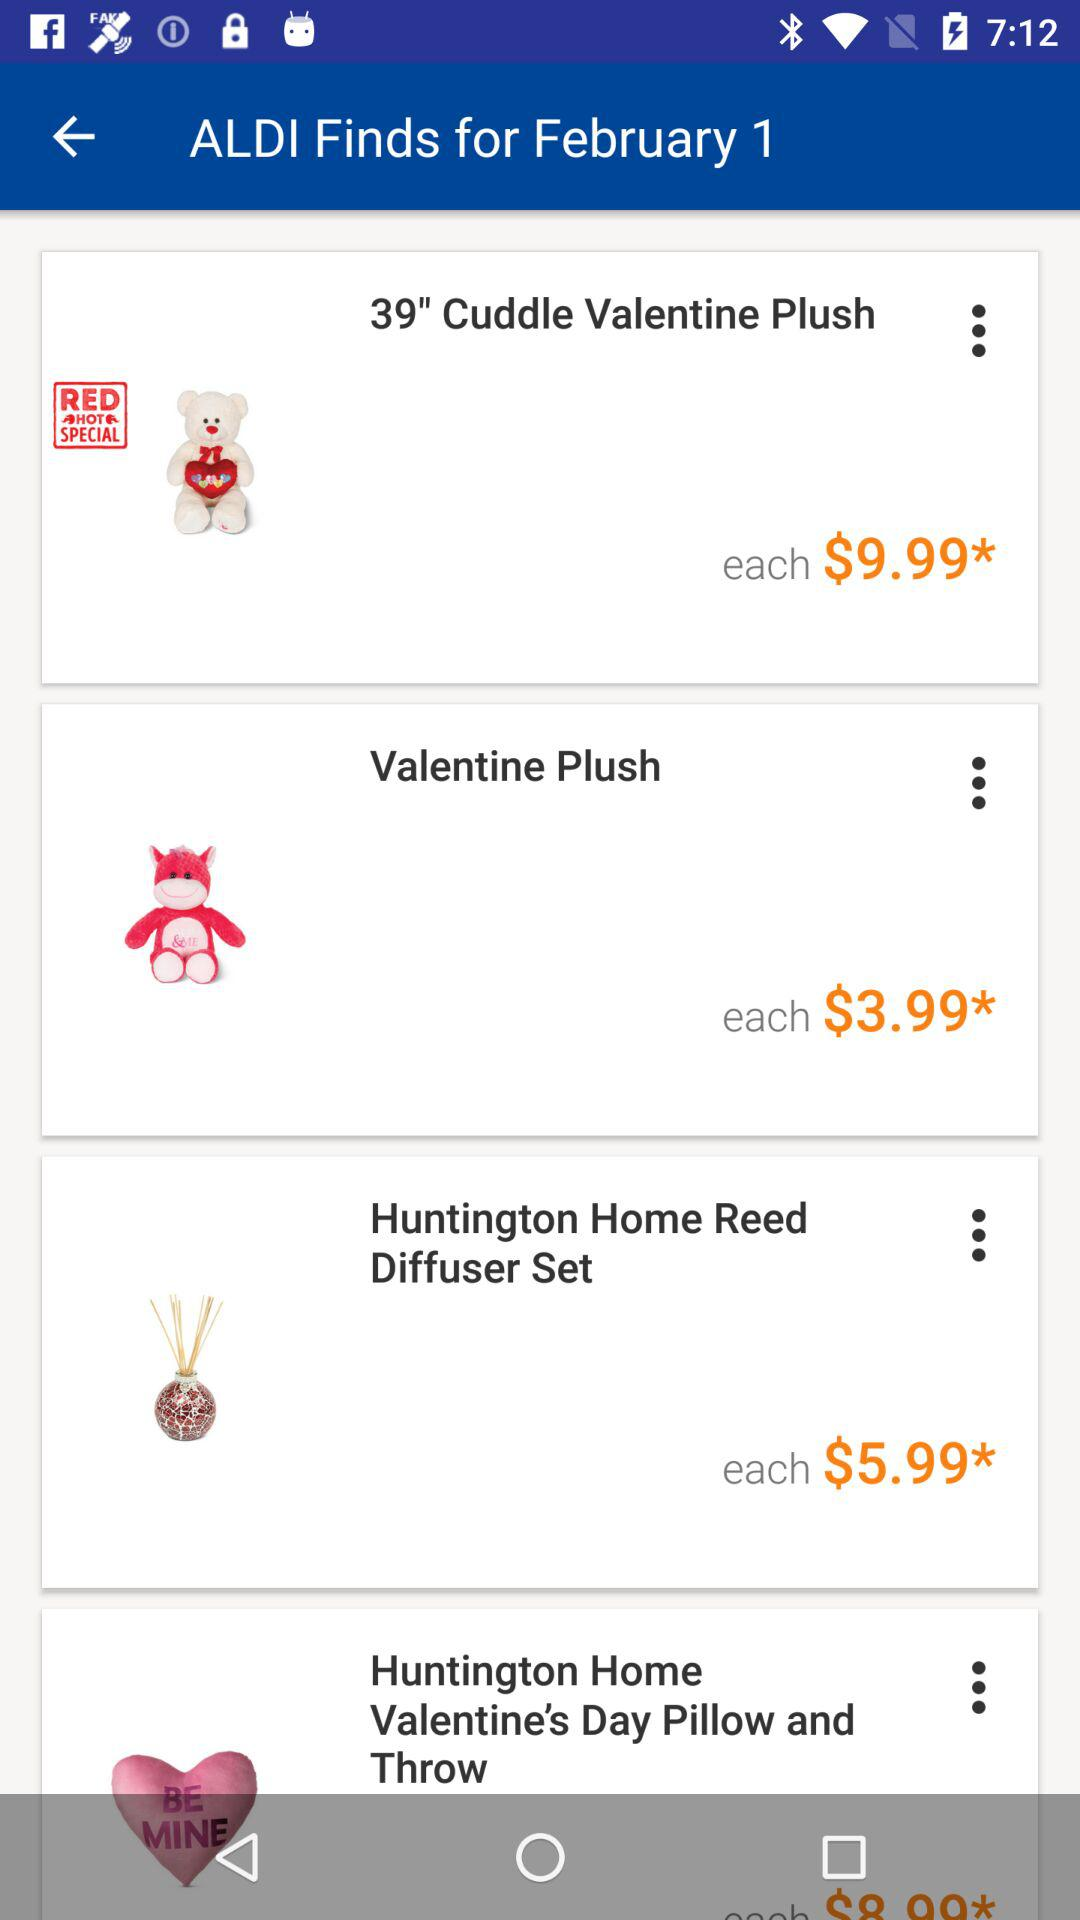What is the price of the "Cuddle Valentine Plush"? The price of the "Cuddle Valentine Plush" is $9.99. 